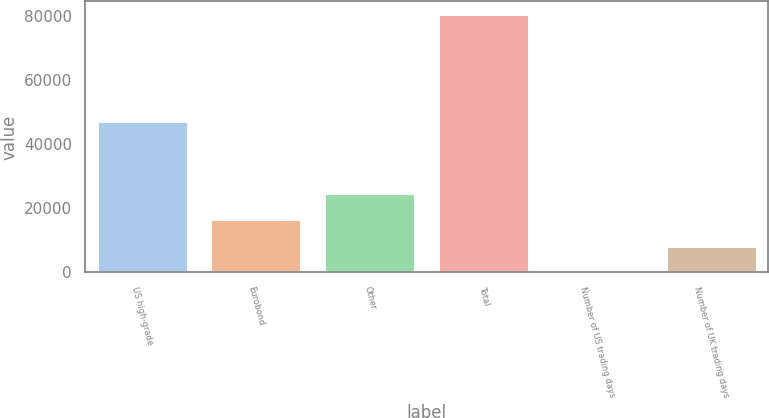Convert chart to OTSL. <chart><loc_0><loc_0><loc_500><loc_500><bar_chart><fcel>US high-grade<fcel>Eurobond<fcel>Other<fcel>Total<fcel>Number of US trading days<fcel>Number of UK trading days<nl><fcel>47019<fcel>16580<fcel>24613<fcel>80394<fcel>64<fcel>8097<nl></chart> 